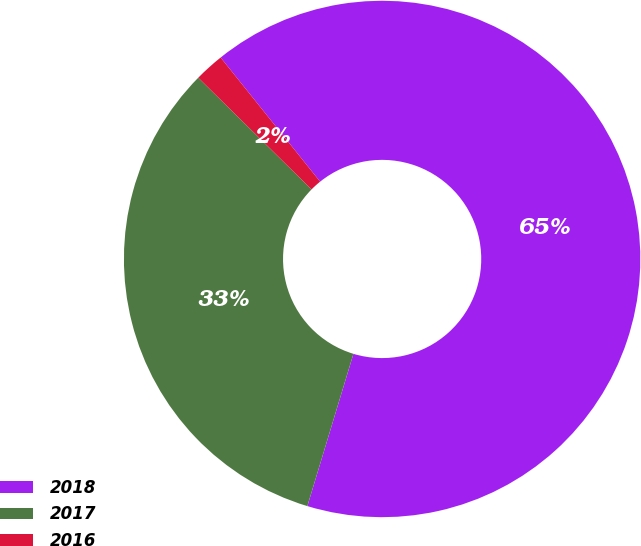Convert chart to OTSL. <chart><loc_0><loc_0><loc_500><loc_500><pie_chart><fcel>2018<fcel>2017<fcel>2016<nl><fcel>65.43%<fcel>32.71%<fcel>1.86%<nl></chart> 